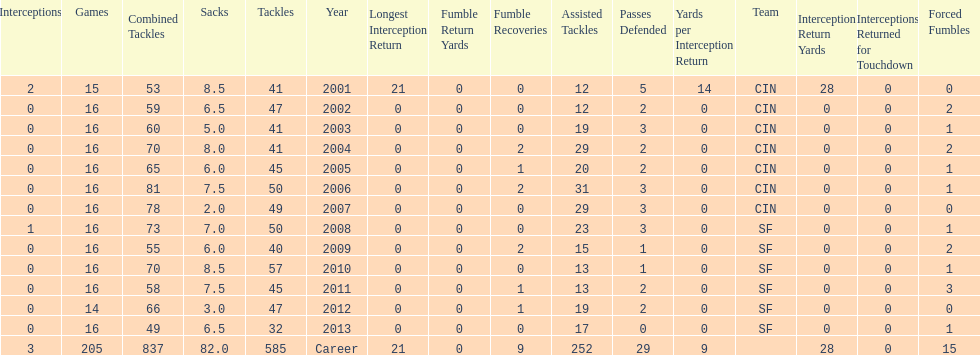How many fumble recoveries did this player have in 2004? 2. 